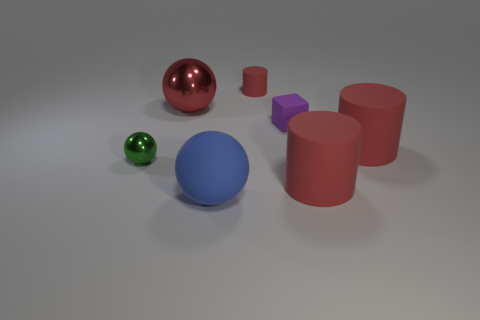Subtract all big balls. How many balls are left? 1 Subtract 1 cylinders. How many cylinders are left? 2 Add 1 gray metallic balls. How many objects exist? 8 Subtract all blue cylinders. Subtract all cyan cubes. How many cylinders are left? 3 Subtract all spheres. How many objects are left? 4 Subtract 0 yellow spheres. How many objects are left? 7 Subtract all tiny purple matte objects. Subtract all yellow cylinders. How many objects are left? 6 Add 4 red things. How many red things are left? 8 Add 7 small red objects. How many small red objects exist? 8 